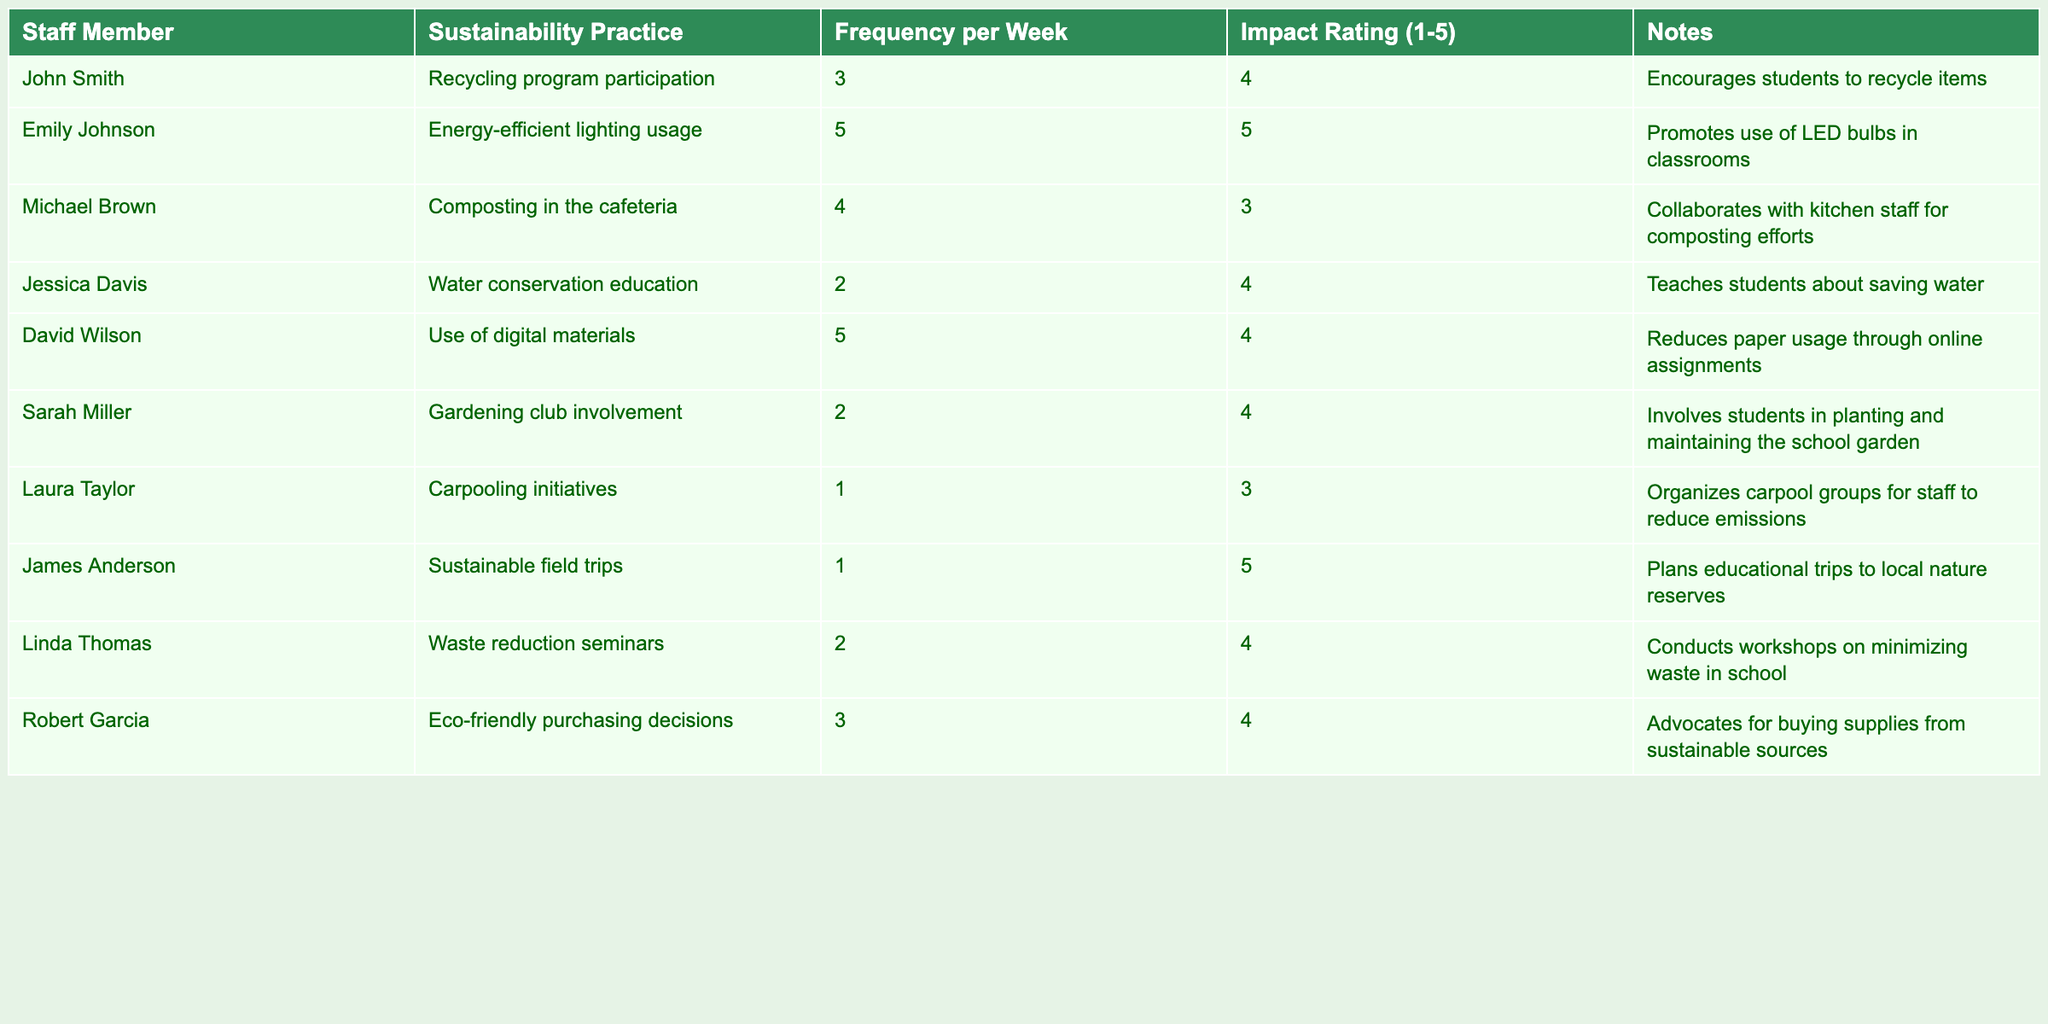What sustainability practice is used most frequently per week? The frequencies of sustainability practices are listed. Looking at the "Frequency per Week" column, "Energy-efficient lighting usage" has the highest frequency of 5, indicating that it is the most frequently used practice.
Answer: Energy-efficient lighting usage How many staff members participate in the composting practice? The table indicates that only Michael Brown is involved in "Composting in the cafeteria," so the number of staff members is 1.
Answer: 1 What is the average impact rating of the sustainability practices? To find the average, add all the impact ratings (4 + 5 + 3 + 4 + 4 + 4 + 3 + 5 + 4 + 4 = 44) and divide by the number of practices (10). The average impact rating is 44/10 = 4.4.
Answer: 4.4 Which staff member reported the highest impact rating? Looking through the "Impact Rating" column, both Emily Johnson and James Anderson reported an impact rating of 5, which is the highest in the table.
Answer: Emily Johnson and James Anderson Are there any staff members who practice sustainability only once a week? From the "Frequency per Week" column, Laura Taylor and James Anderson both participate in sustainability practices just 1 time a week.
Answer: Yes What sustainability practice has the lowest impact rating, and what is that rating? The "Impact Rating" column reveals that "Composting in the cafeteria," assigned to Michael Brown, has the lowest rating of 3. Thus, this is the practice with the lowest impact rating.
Answer: Composting in the cafeteria; 3 How many staff members have an impact rating of 4 or higher? Checking the "Impact Rating" column, the ratings of 4 or higher are assigned to John Smith, Emily Johnson, Jessica Davis, David Wilson, Sarah Miller, Robert Garcia, and Linda Thomas, totaling 7 staff members.
Answer: 7 What percentage of staff members participate in water conservation education? There are 10 staff members in total, and only Jessica Davis participates in water conservation education, representing 1 out of 10. Thus, 1/10 = 0.1 or 10%.
Answer: 10% Is there any staff member involved in gardening initiatives? The table shows that Sarah Miller is involved in the "Gardening club," confirming there is at least one staff member participating in gardening initiatives.
Answer: Yes What is the difference in the frequency of "Use of digital materials" and "Carpooling initiatives"? The frequency for "Use of digital materials" is 5 and "Carpooling initiatives" is 1. The difference is 5 - 1 = 4.
Answer: 4 